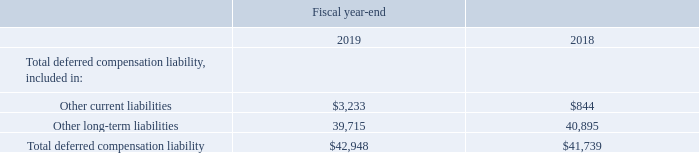Deferred Compensation Plans
Under our deferred compensation plans (‘‘plans’’), eligible employees are permitted to make compensation deferrals up to established limits set under the plans and accrue income on these deferrals based on reference to changes in available investment options. While not required by the plan, we choose to invest in insurance contracts and mutual funds in order to approximate the changes in the liability to the employees. These investments and the liability to the employees were as follows (in thousands):
Life insurance premiums loads, policy fees and cost of insurance that are paid from the asset investments and gains and losses from the asset investments for these plans are recorded as components of other income or expense; such amounts were net gains of $1.1 million in fiscal 2019, $4.8 million in fiscal 2018 and $5.0 million (including a $1.3 million death benefit) in fiscal 2017. Changes in the obligation to plan participants are recorded as a component of operating expenses and cost of sales; such amounts were net losses of $1.5 million in fiscal 2019, $5.2 million in fiscal 2018 and $3.9 million in fiscal 2017. Liabilities associated with participant balances under our deferred compensation plans are affected by individual contributions and distributions made, as well as gains and losses on the participant’s investment allocation election.
What was the Total deferred compensation liability in 2019?
Answer scale should be: thousand. $42,948. What was the  Other long-term liabilities  in 2018?
Answer scale should be: thousand. 40,895. In which years was Total deferred compensation liability calculated? 2019, 2018. In which year was Other long-term liabilities larger? 40,895>39,715
Answer: 2018. What was the change in Other current liabilities from 2018 to 2019?
Answer scale should be: thousand. 3,233-844
Answer: 2389. What was the percentage change in Other current liabilities from 2018 to 2019?
Answer scale should be: percent. (3,233-844)/844
Answer: 283.06. 